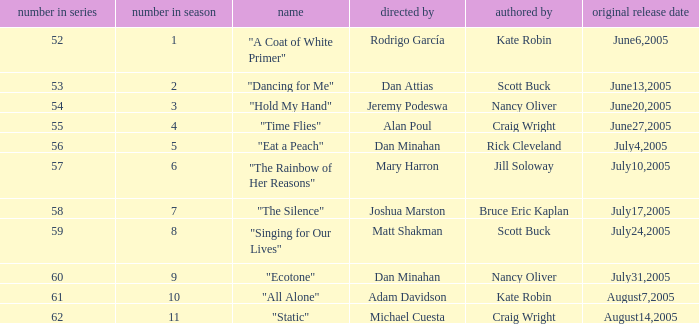What was the name of the episode that was directed by Mary Harron? "The Rainbow of Her Reasons". 